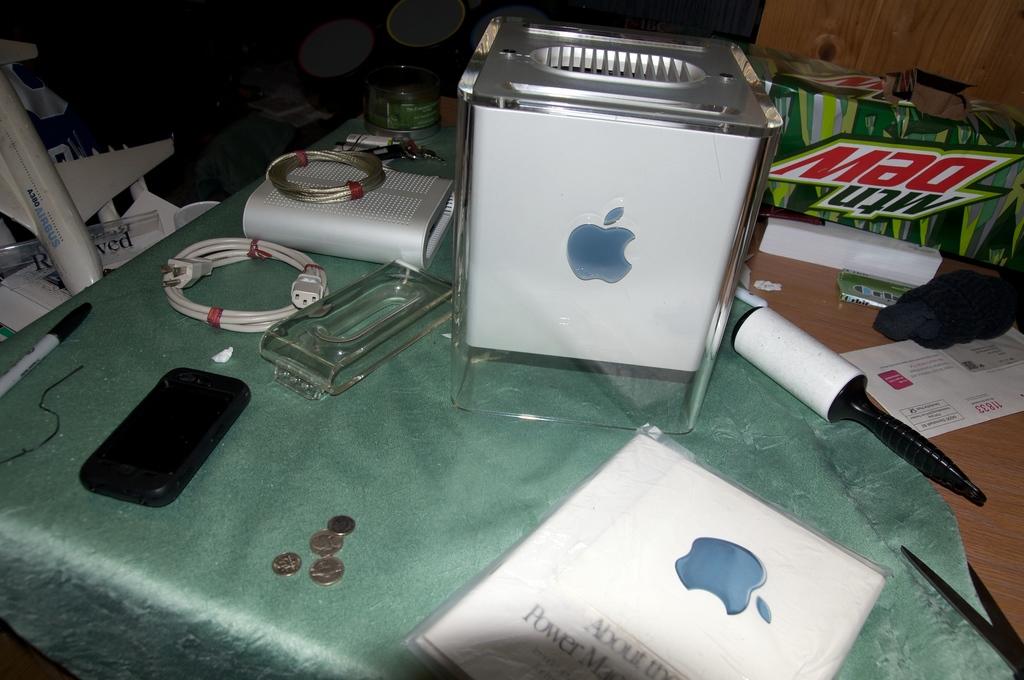What is the beverage in the background?
Provide a succinct answer. Mtn dew. 